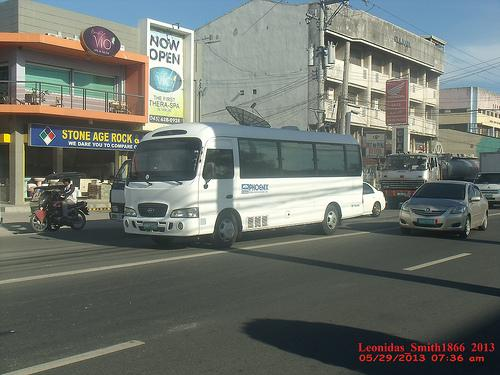What infrastructure details can be observed in this image? A white line on the road, electrical wires, low hanging power lines, and a painted lane divider. Analyze the image to identify a possible reason for the person riding a small vehicle. The person could be using the small vehicle as an efficient and affordable mode of transportation in the busy urban setting. Identify any notable item present on the buildings in the image. A purple sign on top of a building and satellite dish on a building roof. Infer the primary purpose of the large white bus seen in the image. The large white bus serves as a passenger transportation vehicle on city streets. Point out one instance of object interaction in the image. The gray car on the road appears to be switching lanes, possibly to overtake or change direction. In a few words, describe the atmosphere and vibe that this image gives off. Busy urban scene with various modes of transportation and buildings. How many vehicles can be seen in the image, and what are their types? Four vehicles: white bus, gray car, red motorcycle, and truck transporting liquids. Enumerate five distinctive features that you can see in this image. White bus, blue sign, red motorcycle, electrical wires, and white building with balconies. Provide a brief account of the most prominent object in the image. A large white bus traveling down a city street with blue writing on its side. Assess the quality of the image based on the presence of any noise, blur or distortion. The image quality is relatively clear with sufficient details to recognize various objects. Is there a sign on the building that has a yellow background and black text? There is a mention of various signs in the text, such as a blue sign, purple sign, and large red and white sign, but no yellow sign with black text. This represents a wrong attribute. Do you see a flock of birds flying in the sky above the bus? The only mention of the sky includes a small white cloud, part of a blue sky, but no birds. The presence of birds flying would be a wrong attribute. Are there golden statues on top of the building? There is no mention of statues, let alone golden ones, in the text. This refers to objects that do not exist in the image. Is the bus painted in a bright green color? The actual color of the bus mentioned in the text is "white", so the presence of a green bus is a wrong attribute. Are there large trees lining the street where the bus is traveling? No, it's not mentioned in the image. Can you find a neon pink motorcycle with yellow stripes? The motorcycle described in the text is "red", so a neon pink motorcycle with yellow stripes indicates a wrong attribute. 